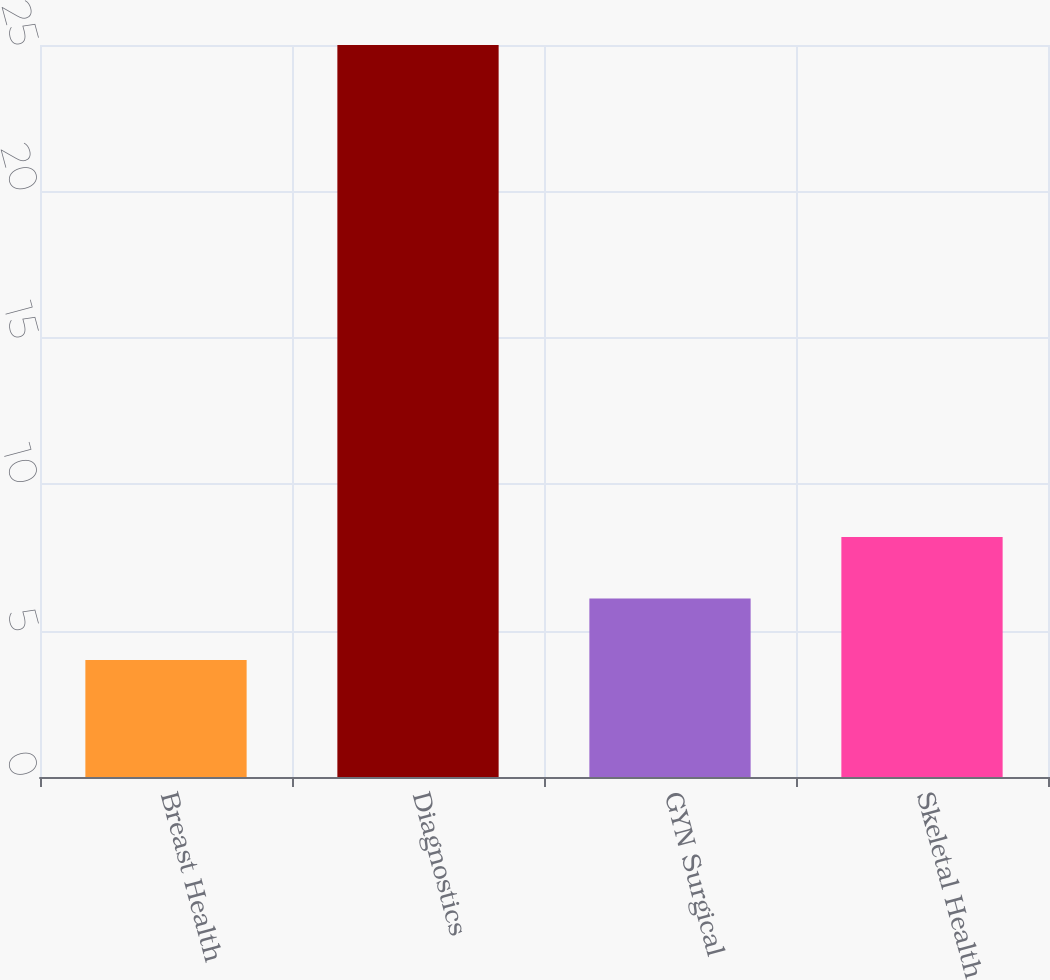Convert chart to OTSL. <chart><loc_0><loc_0><loc_500><loc_500><bar_chart><fcel>Breast Health<fcel>Diagnostics<fcel>GYN Surgical<fcel>Skeletal Health<nl><fcel>4<fcel>25<fcel>6.1<fcel>8.2<nl></chart> 